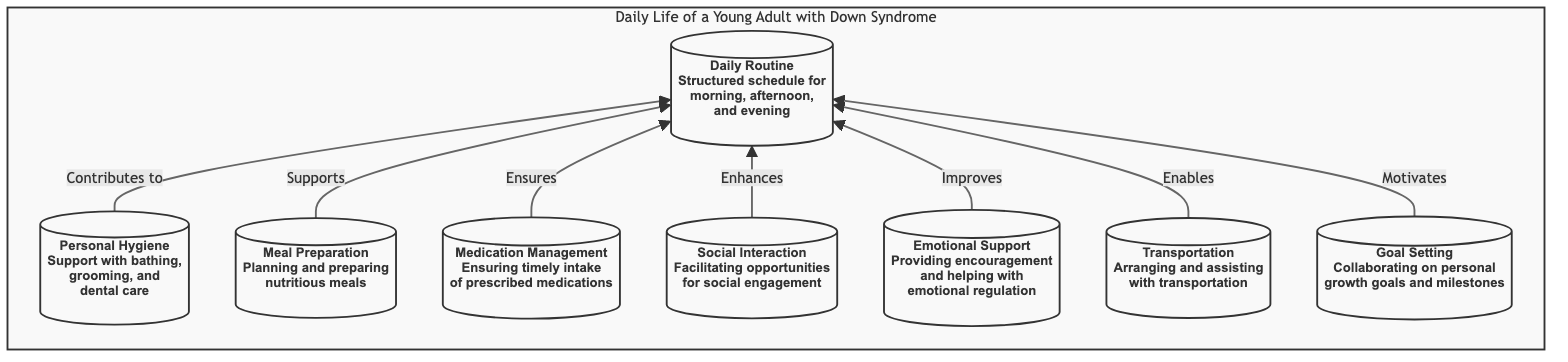What is depicted in the "Daily Routine" node? The "Daily Routine" node describes a structured schedule that includes activities for morning, afternoon, and evening. This node serves as a central component of the caregiving responsibilities.
Answer: Structured schedule that includes activities for morning, afternoon, and evening How many caregiving components are present in the diagram? There are a total of 7 caregiving components (nodes) that contribute to the "Daily Routine." By counting the individual nodes (Personal Hygiene, Meal Preparation, Medication Management, Social Interaction, Emotional Support, Transportation, Goal Setting), we find a total of 7.
Answer: 7 Which caregiving component enables transportation to appointments? The "Transportation" node is responsible for arranging and assisting with transportation to appointments and activities, making it essential for facilitating access to necessary services.
Answer: Transportation What does the "Medication Management" node ensure? The "Medication Management" node ensures the timely intake of prescribed medications for the individual with Down Syndrome, which is crucial for their health and well-being.
Answer: Timely intake of prescribed medications How does "Emotional Support" improve the overall daily routine? The "Emotional Support" node improves the daily routine by providing encouragement, listening, and helping with emotional regulation, which are essential for the individual's mental health and quality of life.
Answer: Improves emotional regulation Which caregiving component is specifically focused on personal growth? The "Goal Setting" component is specifically focused on collaborating on personal growth goals and milestones, providing a framework for development and achievement.
Answer: Goal Setting What effect does "Social Interaction" have on the "Daily Routine"? The "Social Interaction" node enhances the "Daily Routine" by facilitating opportunities for social engagement and community involvement, helping to foster connections and reduce isolation.
Answer: Enhances social engagement Which node describes support with grooming? The "Personal Hygiene" node describes support with bathing, grooming, and dental care, which are essential aspects of daily self-care routines.
Answer: Personal Hygiene 